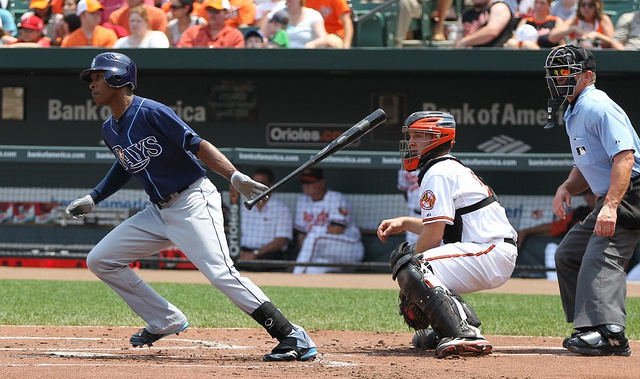Describe the objects in this image and their specific colors. I can see people in darkgray, black, gray, and white tones, people in darkgray, lavender, black, and gray tones, people in darkgray, black, gray, and white tones, people in darkgray, gray, brown, and black tones, and people in darkgray, gray, and black tones in this image. 